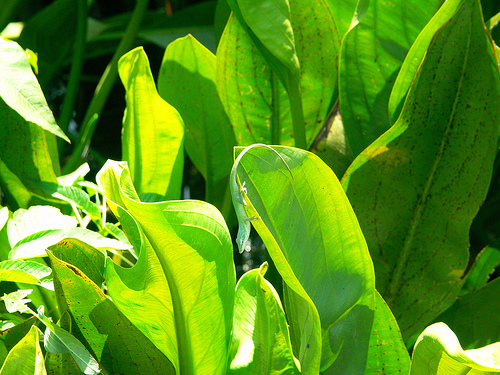<image>
Can you confirm if the lizard is in front of the leaf? No. The lizard is not in front of the leaf. The spatial positioning shows a different relationship between these objects. 